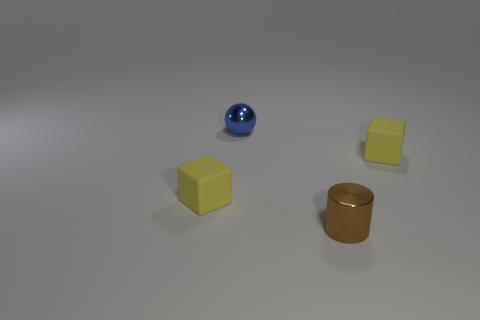There is a object that is both left of the brown thing and in front of the metal ball; how big is it?
Offer a very short reply. Small. Is the number of tiny yellow matte objects that are on the left side of the tiny blue metallic ball greater than the number of cylinders to the right of the brown thing?
Provide a succinct answer. Yes. What number of other things are there of the same shape as the tiny blue object?
Offer a terse response. 0. Are there any small objects behind the small object that is to the right of the tiny brown metallic cylinder?
Your answer should be compact. Yes. What number of brown matte cylinders are there?
Give a very brief answer. 0. Is the number of small brown things greater than the number of small shiny things?
Ensure brevity in your answer.  No. Is there any other thing that is the same color as the ball?
Give a very brief answer. No. What number of other things are there of the same size as the metal ball?
Make the answer very short. 3. There is a small cylinder that is on the right side of the tiny yellow cube that is left of the small rubber block that is to the right of the blue shiny object; what is it made of?
Give a very brief answer. Metal. Do the tiny blue object and the tiny cylinder right of the small blue shiny thing have the same material?
Your answer should be compact. Yes. 